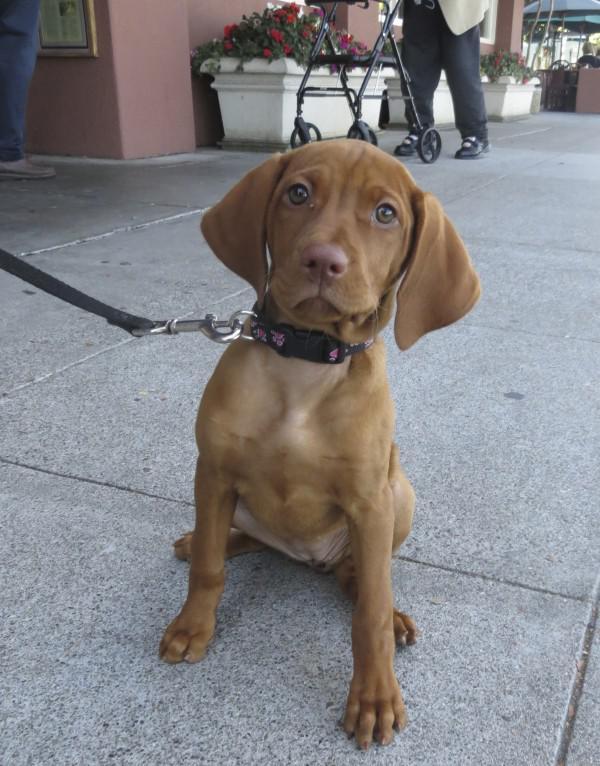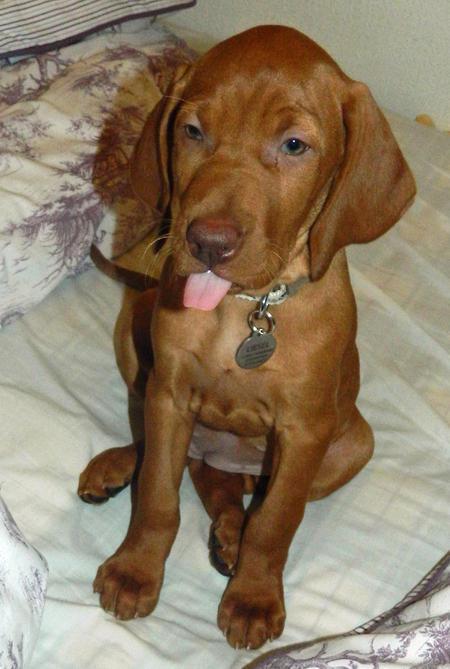The first image is the image on the left, the second image is the image on the right. For the images shown, is this caption "Two dogs are sitting." true? Answer yes or no. Yes. The first image is the image on the left, the second image is the image on the right. Given the left and right images, does the statement "Left and right images each contain a red-orange dog sitting upright, turned forward, and wearing a collar - but only one of the dogs pictured has a tag on a ring dangling from its collar." hold true? Answer yes or no. Yes. 